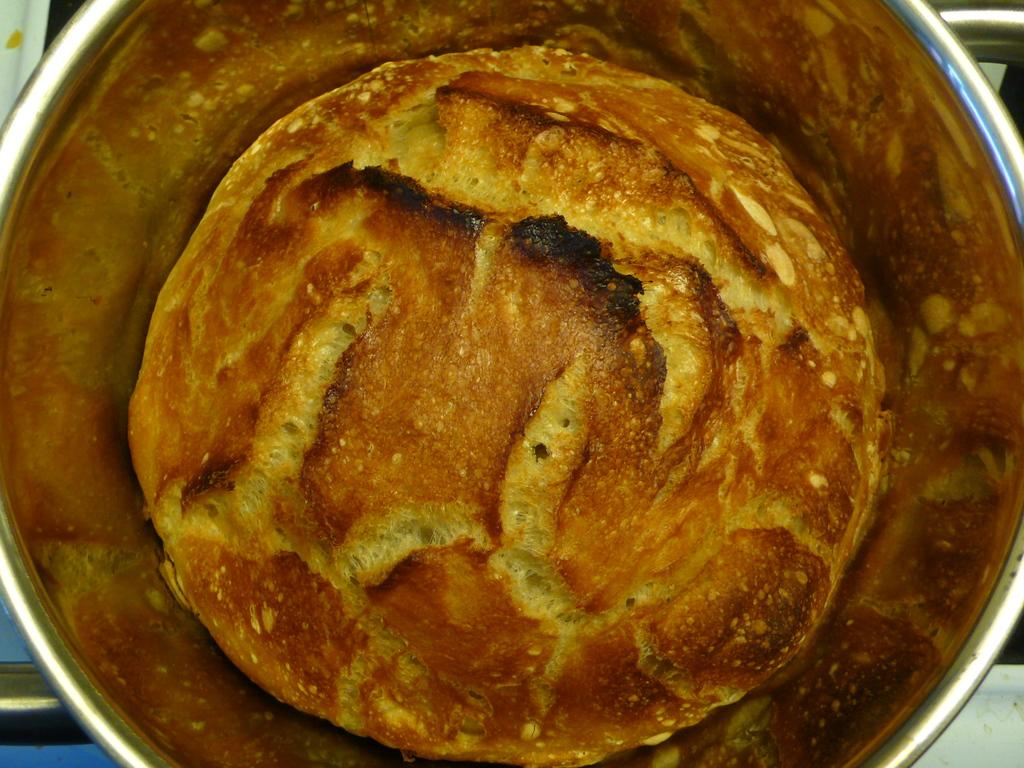What is in the bowl that is visible in the image? There is food in the bowl in the image. Can you describe the appearance of the food in the bowl? The food is in brown and yellow colors. What type of science experiment can be seen starting in the image? There is no science experiment or any indication of a starting process in the image; it only shows food in a bowl. 